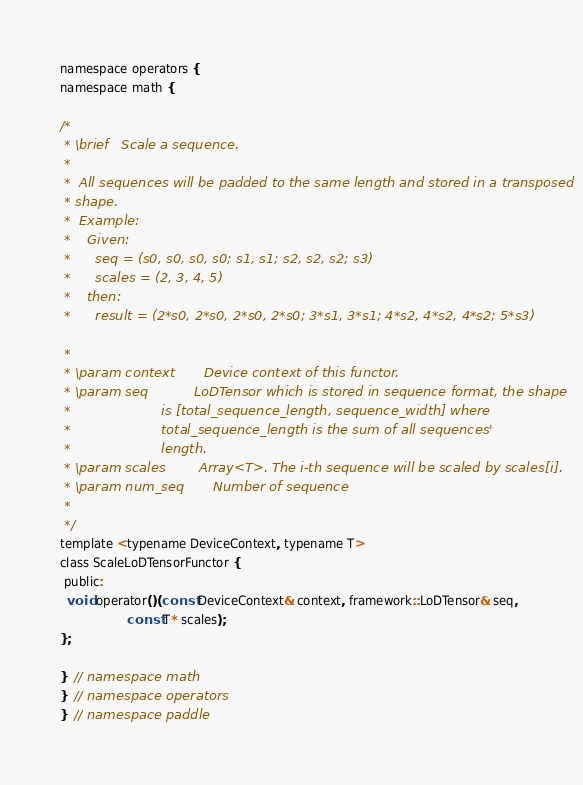Convert code to text. <code><loc_0><loc_0><loc_500><loc_500><_C_>namespace operators {
namespace math {

/*
 * \brief   Scale a sequence.
 *
 *  All sequences will be padded to the same length and stored in a transposed
 * shape.
 *  Example:
 *    Given:
 *      seq = (s0, s0, s0, s0; s1, s1; s2, s2, s2; s3)
 *      scales = (2, 3, 4, 5)
 *    then:
 *      result = (2*s0, 2*s0, 2*s0, 2*s0; 3*s1, 3*s1; 4*s2, 4*s2, 4*s2; 5*s3)

 *
 * \param context       Device context of this functor.
 * \param seq           LoDTensor which is stored in sequence format, the shape
 *                      is [total_sequence_length, sequence_width] where
 *                      total_sequence_length is the sum of all sequences'
 *                      length.
 * \param scales        Array<T>. The i-th sequence will be scaled by scales[i].
 * \param num_seq       Number of sequence
 *
 */
template <typename DeviceContext, typename T>
class ScaleLoDTensorFunctor {
 public:
  void operator()(const DeviceContext& context, framework::LoDTensor& seq,
                  const T* scales);
};

}  // namespace math
}  // namespace operators
}  // namespace paddle
</code> 